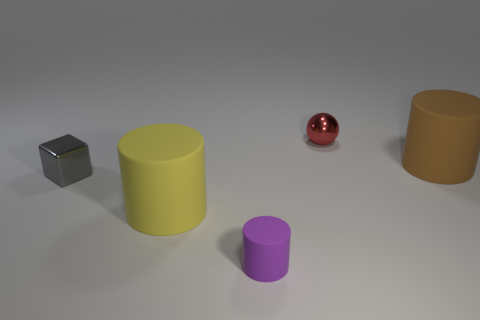What color is the shiny block?
Make the answer very short. Gray. How many red cylinders are there?
Your response must be concise. 0. What number of small matte objects are the same color as the tiny shiny sphere?
Provide a succinct answer. 0. Is the shape of the shiny object right of the metallic cube the same as the shiny thing that is to the left of the yellow cylinder?
Provide a succinct answer. No. What is the color of the large thing that is in front of the rubber object to the right of the metal object right of the tiny purple matte cylinder?
Your response must be concise. Yellow. The large object that is in front of the small gray shiny cube is what color?
Your answer should be very brief. Yellow. What color is the other matte object that is the same size as the brown thing?
Provide a short and direct response. Yellow. Is the size of the shiny cube the same as the purple matte object?
Your response must be concise. Yes. What number of small red metallic objects are behind the gray cube?
Provide a succinct answer. 1. What number of objects are big matte cylinders that are behind the small gray metallic object or cyan balls?
Provide a succinct answer. 1. 